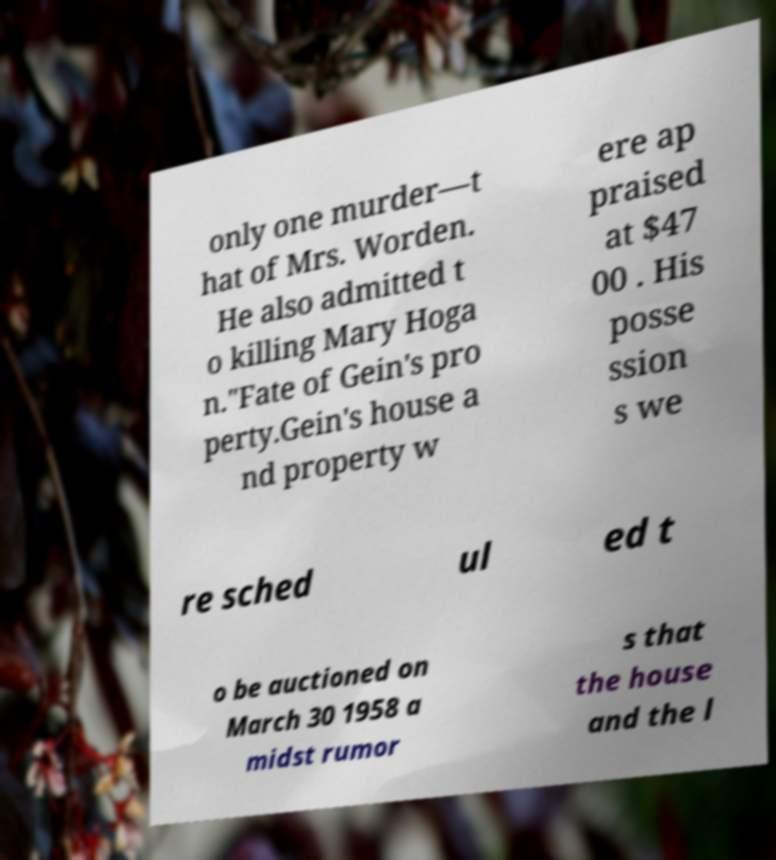Can you read and provide the text displayed in the image?This photo seems to have some interesting text. Can you extract and type it out for me? only one murder—t hat of Mrs. Worden. He also admitted t o killing Mary Hoga n."Fate of Gein's pro perty.Gein's house a nd property w ere ap praised at $47 00 . His posse ssion s we re sched ul ed t o be auctioned on March 30 1958 a midst rumor s that the house and the l 